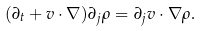<formula> <loc_0><loc_0><loc_500><loc_500>( \partial _ { t } + v \cdot \nabla ) \partial _ { j } \rho = \partial _ { j } v \cdot \nabla \rho .</formula> 